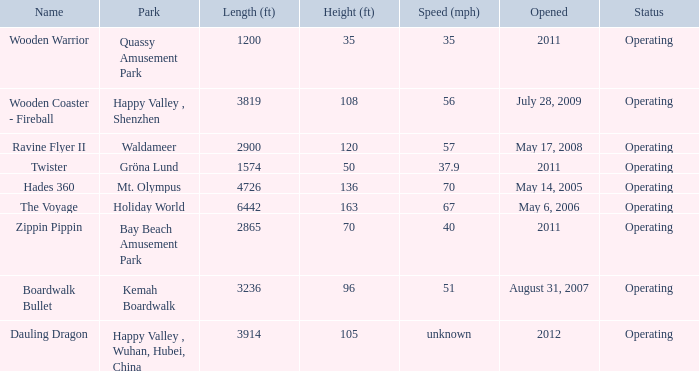What is the length of the coaster with the unknown speed 3914.0. 